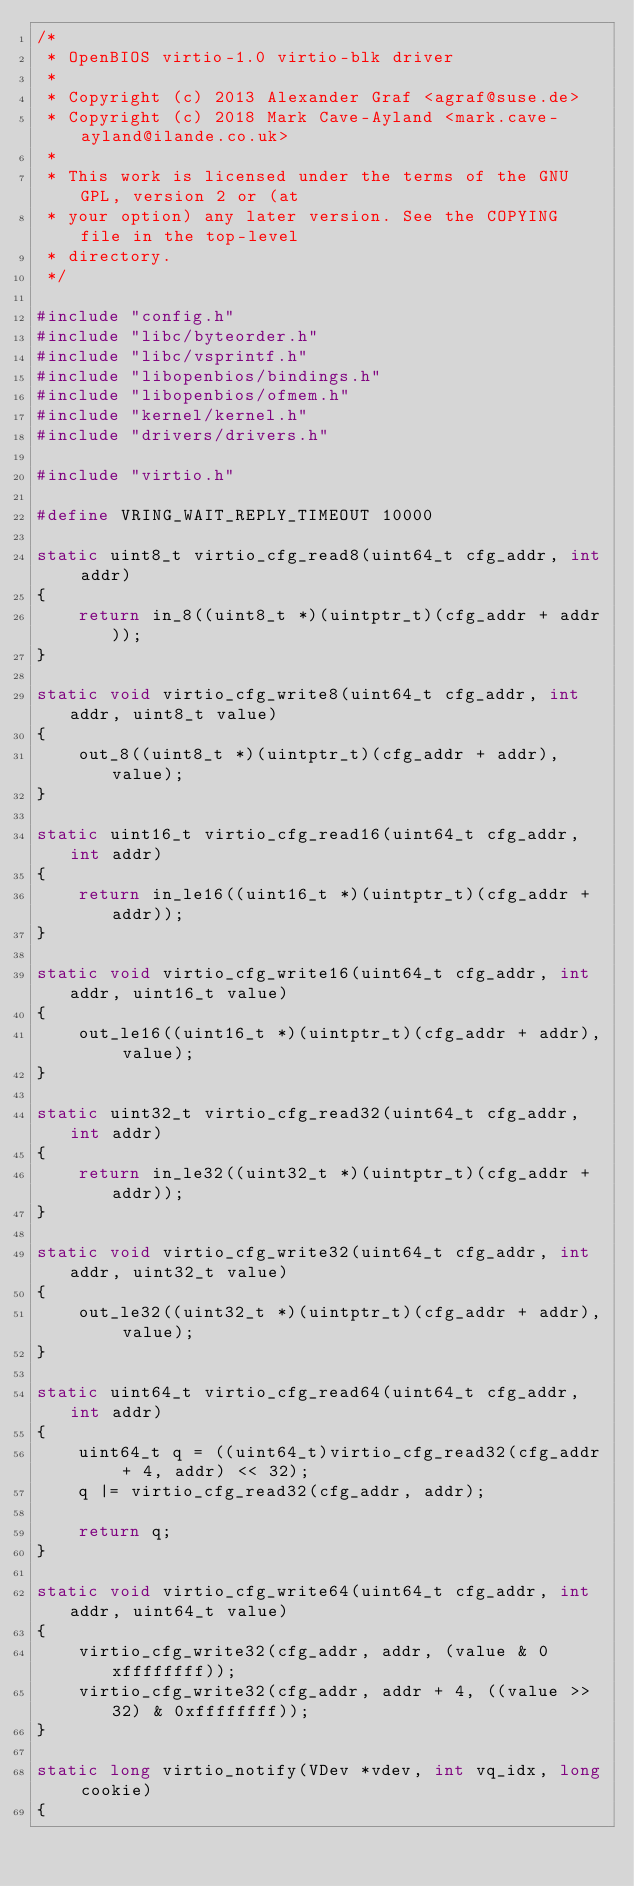Convert code to text. <code><loc_0><loc_0><loc_500><loc_500><_C_>/*
 * OpenBIOS virtio-1.0 virtio-blk driver
 *
 * Copyright (c) 2013 Alexander Graf <agraf@suse.de>
 * Copyright (c) 2018 Mark Cave-Ayland <mark.cave-ayland@ilande.co.uk>
 *
 * This work is licensed under the terms of the GNU GPL, version 2 or (at
 * your option) any later version. See the COPYING file in the top-level
 * directory.
 */

#include "config.h"
#include "libc/byteorder.h"
#include "libc/vsprintf.h"
#include "libopenbios/bindings.h"
#include "libopenbios/ofmem.h"
#include "kernel/kernel.h"
#include "drivers/drivers.h"

#include "virtio.h"

#define VRING_WAIT_REPLY_TIMEOUT 10000

static uint8_t virtio_cfg_read8(uint64_t cfg_addr, int addr)
{
    return in_8((uint8_t *)(uintptr_t)(cfg_addr + addr));
}

static void virtio_cfg_write8(uint64_t cfg_addr, int addr, uint8_t value)
{
    out_8((uint8_t *)(uintptr_t)(cfg_addr + addr), value);
}

static uint16_t virtio_cfg_read16(uint64_t cfg_addr, int addr)
{
    return in_le16((uint16_t *)(uintptr_t)(cfg_addr + addr));
}

static void virtio_cfg_write16(uint64_t cfg_addr, int addr, uint16_t value)
{
    out_le16((uint16_t *)(uintptr_t)(cfg_addr + addr), value);
}

static uint32_t virtio_cfg_read32(uint64_t cfg_addr, int addr)
{
    return in_le32((uint32_t *)(uintptr_t)(cfg_addr + addr));
}

static void virtio_cfg_write32(uint64_t cfg_addr, int addr, uint32_t value)
{
    out_le32((uint32_t *)(uintptr_t)(cfg_addr + addr), value);
}

static uint64_t virtio_cfg_read64(uint64_t cfg_addr, int addr)
{
    uint64_t q = ((uint64_t)virtio_cfg_read32(cfg_addr + 4, addr) << 32);
    q |= virtio_cfg_read32(cfg_addr, addr);

    return q;
}

static void virtio_cfg_write64(uint64_t cfg_addr, int addr, uint64_t value)
{
    virtio_cfg_write32(cfg_addr, addr, (value & 0xffffffff));
    virtio_cfg_write32(cfg_addr, addr + 4, ((value >> 32) & 0xffffffff));
}

static long virtio_notify(VDev *vdev, int vq_idx, long cookie)
{</code> 